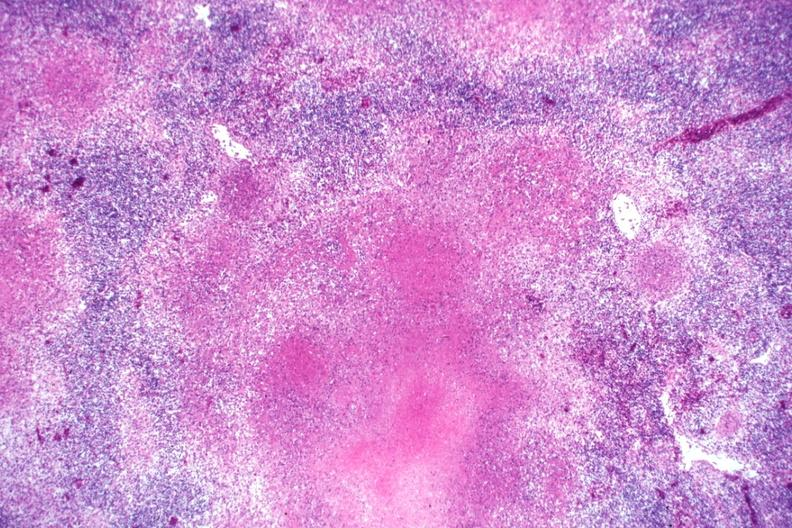does this image show typical necrotizing granulomata becoming confluent an excellent slide?
Answer the question using a single word or phrase. Yes 